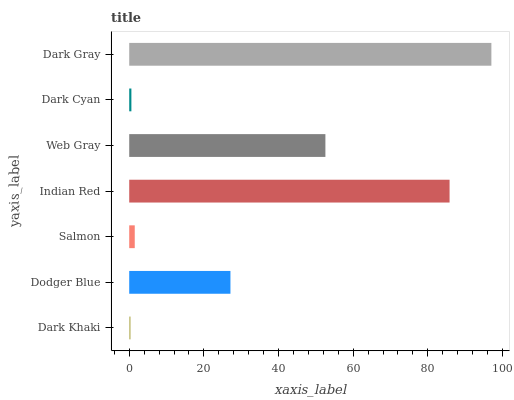Is Dark Khaki the minimum?
Answer yes or no. Yes. Is Dark Gray the maximum?
Answer yes or no. Yes. Is Dodger Blue the minimum?
Answer yes or no. No. Is Dodger Blue the maximum?
Answer yes or no. No. Is Dodger Blue greater than Dark Khaki?
Answer yes or no. Yes. Is Dark Khaki less than Dodger Blue?
Answer yes or no. Yes. Is Dark Khaki greater than Dodger Blue?
Answer yes or no. No. Is Dodger Blue less than Dark Khaki?
Answer yes or no. No. Is Dodger Blue the high median?
Answer yes or no. Yes. Is Dodger Blue the low median?
Answer yes or no. Yes. Is Dark Khaki the high median?
Answer yes or no. No. Is Dark Gray the low median?
Answer yes or no. No. 